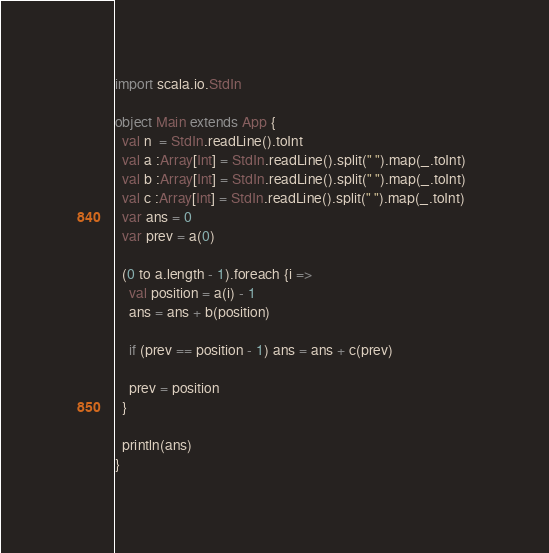<code> <loc_0><loc_0><loc_500><loc_500><_Scala_>import scala.io.StdIn

object Main extends App {
  val n  = StdIn.readLine().toInt
  val a :Array[Int] = StdIn.readLine().split(" ").map(_.toInt)
  val b :Array[Int] = StdIn.readLine().split(" ").map(_.toInt)
  val c :Array[Int] = StdIn.readLine().split(" ").map(_.toInt)  
  var ans = 0
  var prev = a(0)

  (0 to a.length - 1).foreach {i =>
    val position = a(i) - 1
    ans = ans + b(position)

    if (prev == position - 1) ans = ans + c(prev)

    prev = position
  }

  println(ans)
}
</code> 